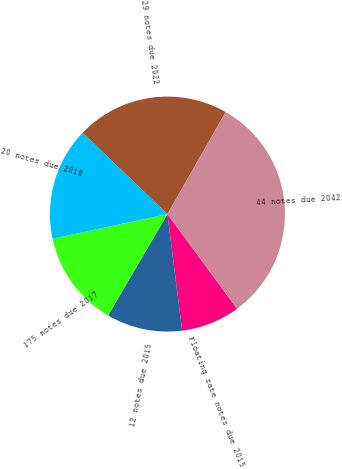Convert chart to OTSL. <chart><loc_0><loc_0><loc_500><loc_500><pie_chart><fcel>Floating rate notes due 2015<fcel>12 notes due 2015<fcel>175 notes due 2017<fcel>20 notes due 2018<fcel>29 notes due 2022<fcel>44 notes due 2042<nl><fcel>8.09%<fcel>10.43%<fcel>13.2%<fcel>15.54%<fcel>21.08%<fcel>31.65%<nl></chart> 